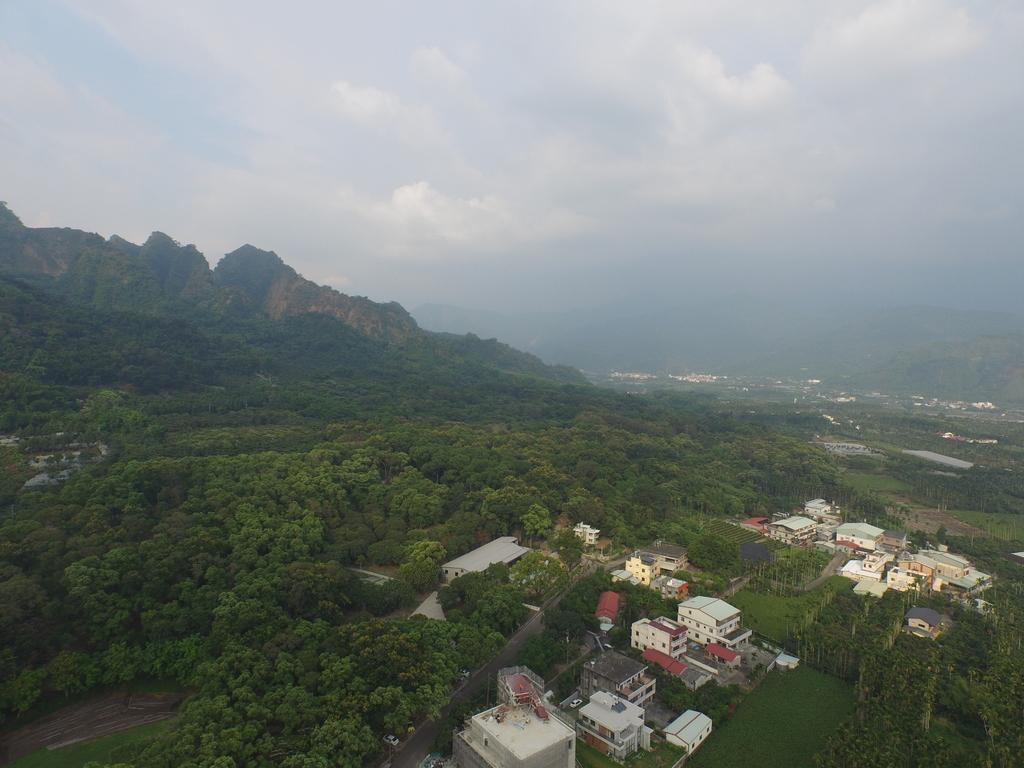What type of structures can be seen in the image? There are many buildings in the image. What other natural elements are present in the image? There are trees in the image. What can be seen in the distance in the image? There are mountains visible in the background of the image. What is the condition of the sky in the image? The sky is visible in the background of the image, and there are clouds present. Where is the manager sitting on a swing in the image? There is no manager or swing present in the image. 